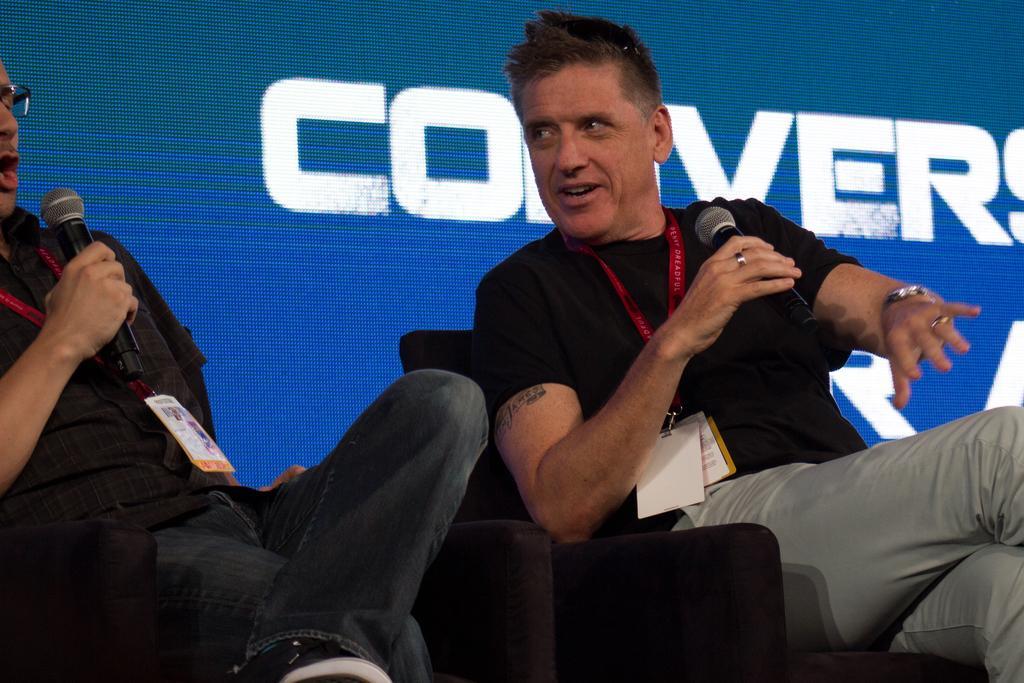Describe this image in one or two sentences. In this image we can see two persons holding microphones and wearing id cards are sitting on chairs. In the background, we can see a screen with some text. 